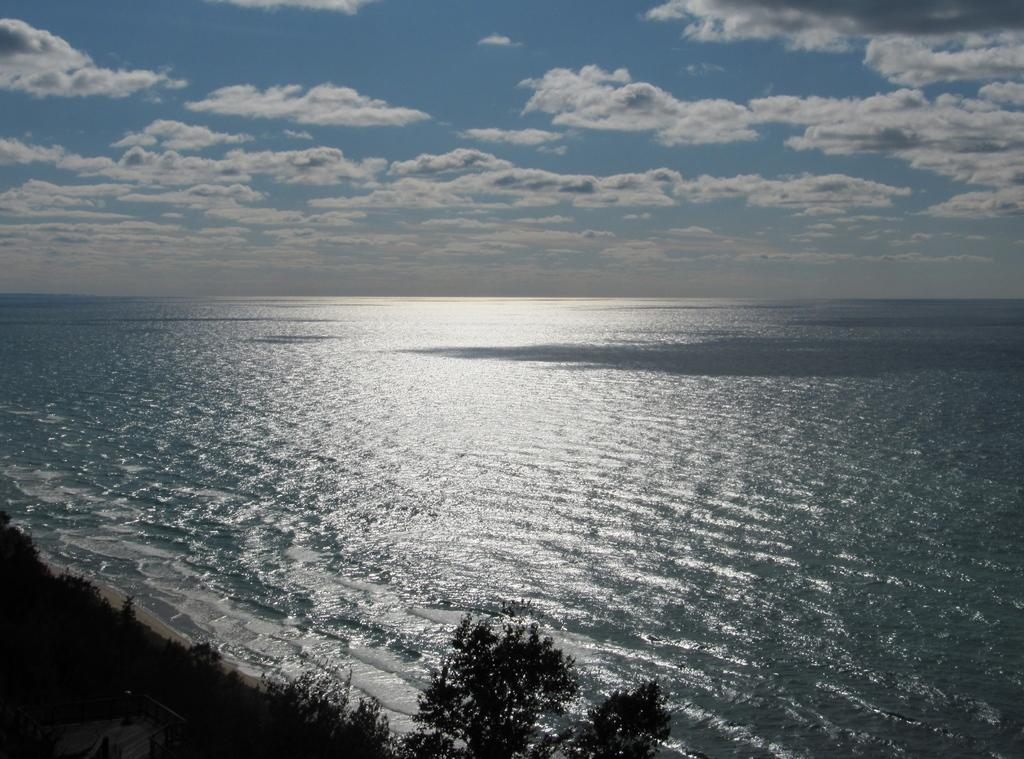What type of vegetation can be seen in the image? There are trees in the image. What else is visible besides the trees? There is water visible in the image. What can be seen in the background of the image? The sky is visible in the background of the image. How many boys are playing with the patch in the image? There are no boys or patches present in the image. What type of porter is carrying the water in the image? There is no porter present in the image, and the water is not being carried by anyone. 